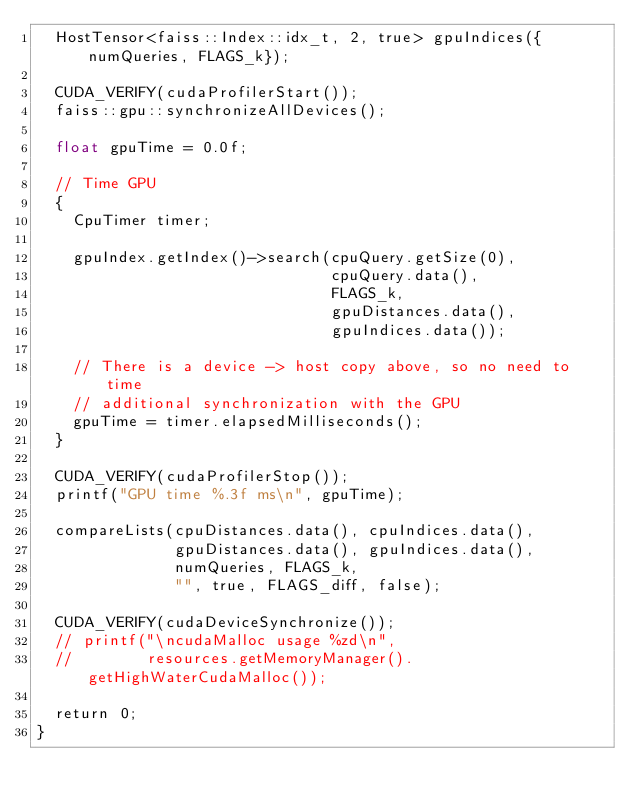<code> <loc_0><loc_0><loc_500><loc_500><_Cuda_>  HostTensor<faiss::Index::idx_t, 2, true> gpuIndices({numQueries, FLAGS_k});

  CUDA_VERIFY(cudaProfilerStart());
  faiss::gpu::synchronizeAllDevices();

  float gpuTime = 0.0f;

  // Time GPU
  {
    CpuTimer timer;

    gpuIndex.getIndex()->search(cpuQuery.getSize(0),
                                cpuQuery.data(),
                                FLAGS_k,
                                gpuDistances.data(),
                                gpuIndices.data());

    // There is a device -> host copy above, so no need to time
    // additional synchronization with the GPU
    gpuTime = timer.elapsedMilliseconds();
  }

  CUDA_VERIFY(cudaProfilerStop());
  printf("GPU time %.3f ms\n", gpuTime);

  compareLists(cpuDistances.data(), cpuIndices.data(),
               gpuDistances.data(), gpuIndices.data(),
               numQueries, FLAGS_k,
               "", true, FLAGS_diff, false);

  CUDA_VERIFY(cudaDeviceSynchronize());
  // printf("\ncudaMalloc usage %zd\n",
  //        resources.getMemoryManager().getHighWaterCudaMalloc());

  return 0;
}
</code> 